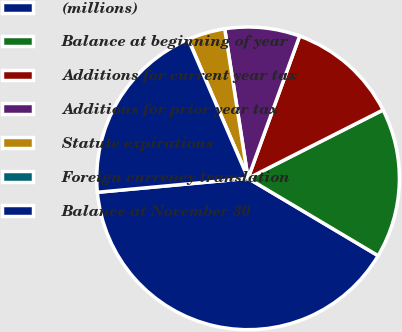Convert chart. <chart><loc_0><loc_0><loc_500><loc_500><pie_chart><fcel>(millions)<fcel>Balance at beginning of year<fcel>Additions for current year tax<fcel>Additions for prior year tax<fcel>Statute expirations<fcel>Foreign currency translation<fcel>Balance at November 30<nl><fcel>39.99%<fcel>16.0%<fcel>12.0%<fcel>8.0%<fcel>4.0%<fcel>0.0%<fcel>20.0%<nl></chart> 